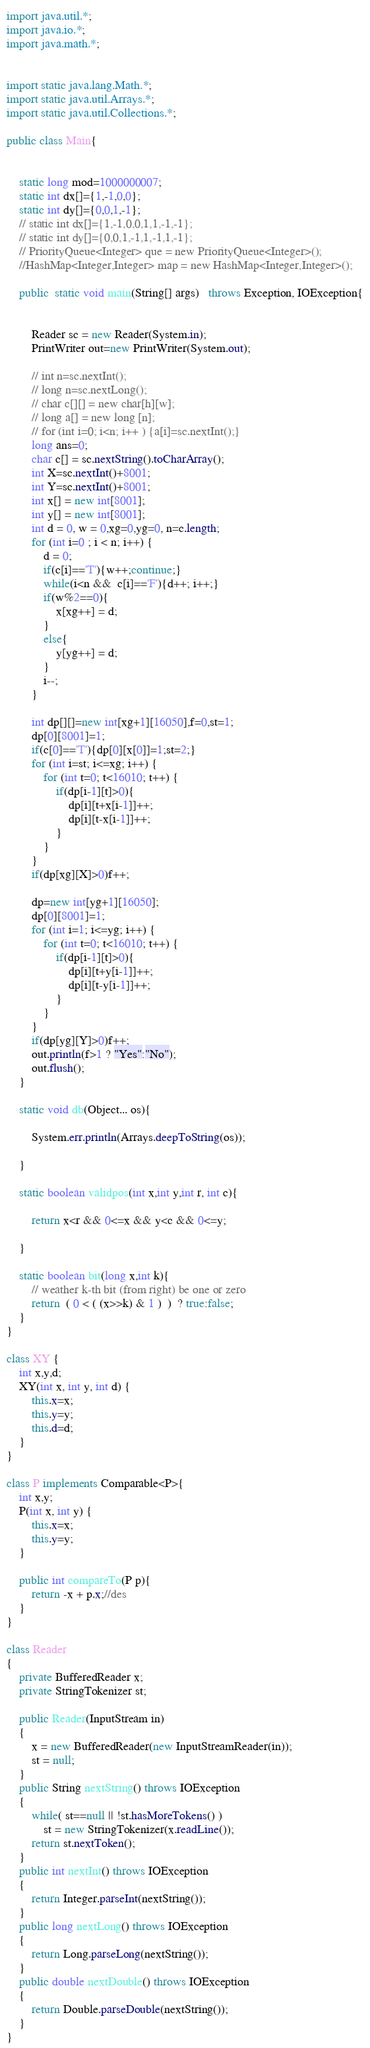Convert code to text. <code><loc_0><loc_0><loc_500><loc_500><_Java_>import java.util.*;
import java.io.*;
import java.math.*;
 
 
import static java.lang.Math.*;
import static java.util.Arrays.*;
import static java.util.Collections.*;
 
public class Main{ 
 
 
    static long mod=1000000007;
    static int dx[]={1,-1,0,0};
    static int dy[]={0,0,1,-1};
    // static int dx[]={1,-1,0,0,1,1,-1,-1};
    // static int dy[]={0,0,1,-1,1,-1,1,-1};
    // PriorityQueue<Integer> que = new PriorityQueue<Integer>(); 
    //HashMap<Integer,Integer> map = new HashMap<Integer,Integer>();
 
    public  static void main(String[] args)   throws Exception, IOException{
     
        
        Reader sc = new Reader(System.in);
        PrintWriter out=new PrintWriter(System.out);
     
        // int n=sc.nextInt();
        // long n=sc.nextLong();
        // char c[][] = new char[h][w];
        // long a[] = new long [n];
        // for (int i=0; i<n; i++ ) {a[i]=sc.nextInt();}
        long ans=0;
        char c[] = sc.nextString().toCharArray();
        int X=sc.nextInt()+8001;
        int Y=sc.nextInt()+8001;
        int x[] = new int[8001];
        int y[] = new int[8001];
        int d = 0, w = 0,xg=0,yg=0, n=c.length;
        for (int i=0 ; i < n; i++) {
            d = 0;
            if(c[i]=='T'){w++;continue;}
            while(i<n &&  c[i]=='F'){d++; i++;}
            if(w%2==0){
                x[xg++] = d;
            }
            else{
                y[yg++] = d;
            }
            i--;
        }

        int dp[][]=new int[xg+1][16050],f=0,st=1;
        dp[0][8001]=1;
        if(c[0]=='T'){dp[0][x[0]]=1;st=2;}
        for (int i=st; i<=xg; i++) {
            for (int t=0; t<16010; t++) {
                if(dp[i-1][t]>0){
                    dp[i][t+x[i-1]]++;
                    dp[i][t-x[i-1]]++;
                }
            }
        }
        if(dp[xg][X]>0)f++;

        dp=new int[yg+1][16050];
        dp[0][8001]=1;
        for (int i=1; i<=yg; i++) {
            for (int t=0; t<16010; t++) {
                if(dp[i-1][t]>0){
                    dp[i][t+y[i-1]]++;
                    dp[i][t-y[i-1]]++;
                }
            }
        }
        if(dp[yg][Y]>0)f++;
        out.println(f>1 ? "Yes":"No");
        out.flush();
    }

    static void db(Object... os){
     
        System.err.println(Arrays.deepToString(os));
     
    }
     
    static boolean validpos(int x,int y,int r, int c){
        
        return x<r && 0<=x && y<c && 0<=y;
        
    }
     
    static boolean bit(long x,int k){
        // weather k-th bit (from right) be one or zero
        return  ( 0 < ( (x>>k) & 1 )  )  ? true:false;
    }    
}

class XY {
    int x,y,d;
    XY(int x, int y, int d) {
        this.x=x;
        this.y=y;
        this.d=d;
    } 
}
 
class P implements Comparable<P>{
    int x,y;
    P(int x, int y) {
        this.x=x;
        this.y=y;
    } 
      
    public int compareTo(P p){
        return -x + p.x;//des
    } 
}
 
class Reader
{ 
    private BufferedReader x;
    private StringTokenizer st;
    
    public Reader(InputStream in)
    {
        x = new BufferedReader(new InputStreamReader(in));
        st = null;
    }
    public String nextString() throws IOException
    {
        while( st==null || !st.hasMoreTokens() )
            st = new StringTokenizer(x.readLine());
        return st.nextToken();
    }
    public int nextInt() throws IOException
    {
        return Integer.parseInt(nextString());
    }
    public long nextLong() throws IOException
    {
        return Long.parseLong(nextString());
    }
    public double nextDouble() throws IOException
    {
        return Double.parseDouble(nextString());
    }
}</code> 